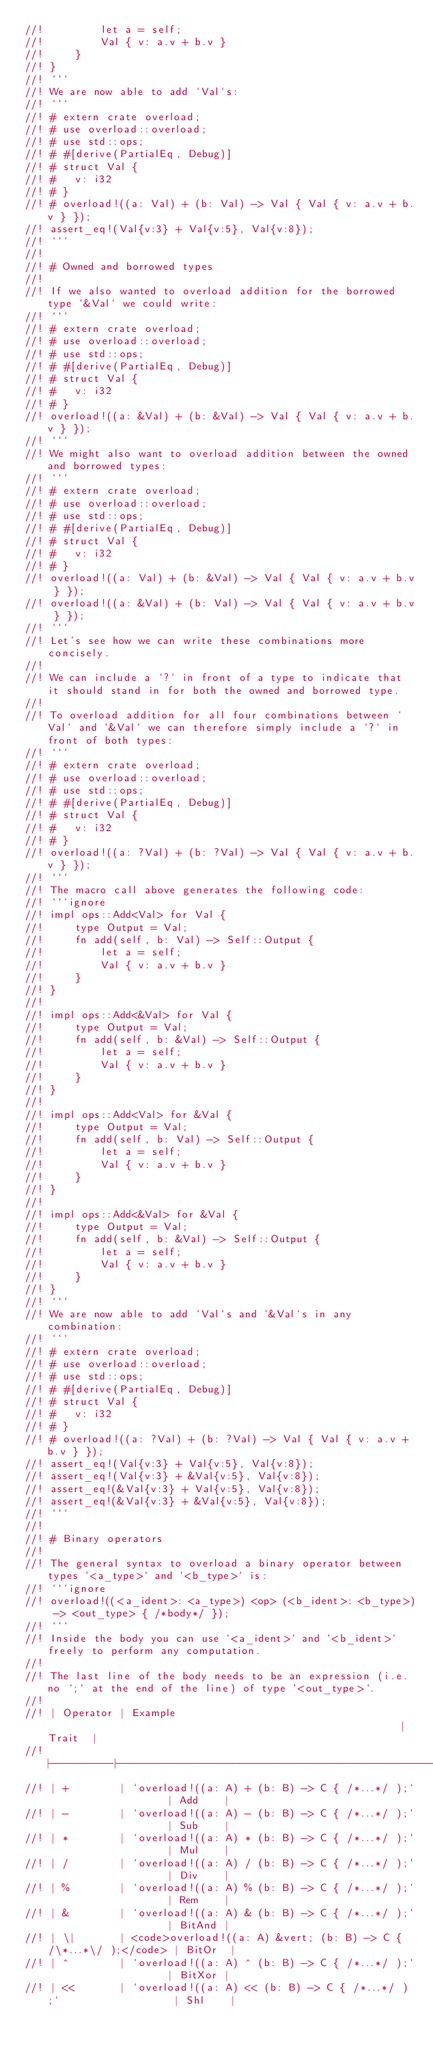<code> <loc_0><loc_0><loc_500><loc_500><_Rust_>//!         let a = self;
//!         Val { v: a.v + b.v }
//!     }
//! }
//! ```
//! We are now able to add `Val`s:
//! ```
//! # extern crate overload;
//! # use overload::overload;
//! # use std::ops;
//! # #[derive(PartialEq, Debug)]
//! # struct Val {
//! #   v: i32
//! # }
//! # overload!((a: Val) + (b: Val) -> Val { Val { v: a.v + b.v } });
//! assert_eq!(Val{v:3} + Val{v:5}, Val{v:8});
//! ```
//! 
//! # Owned and borrowed types
//! 
//! If we also wanted to overload addition for the borrowed type `&Val` we could write:
//! ```
//! # extern crate overload;
//! # use overload::overload;
//! # use std::ops;
//! # #[derive(PartialEq, Debug)]
//! # struct Val {
//! #   v: i32
//! # }
//! overload!((a: &Val) + (b: &Val) -> Val { Val { v: a.v + b.v } });
//! ```
//! We might also want to overload addition between the owned and borrowed types:
//! ```
//! # extern crate overload;
//! # use overload::overload;
//! # use std::ops;
//! # #[derive(PartialEq, Debug)]
//! # struct Val {
//! #   v: i32
//! # }
//! overload!((a: Val) + (b: &Val) -> Val { Val { v: a.v + b.v } });
//! overload!((a: &Val) + (b: Val) -> Val { Val { v: a.v + b.v } });
//! ```
//! Let's see how we can write these combinations more concisely.
//! 
//! We can include a `?` in front of a type to indicate that it should stand in for both the owned and borrowed type.
//! 
//! To overload addition for all four combinations between `Val` and `&Val` we can therefore simply include a `?` in front of both types:
//! ```
//! # extern crate overload;
//! # use overload::overload;
//! # use std::ops;
//! # #[derive(PartialEq, Debug)]
//! # struct Val {
//! #   v: i32
//! # }
//! overload!((a: ?Val) + (b: ?Val) -> Val { Val { v: a.v + b.v } });
//! ```
//! The macro call above generates the following code:
//! ```ignore
//! impl ops::Add<Val> for Val {
//!     type Output = Val;
//!     fn add(self, b: Val) -> Self::Output {
//!         let a = self;
//!         Val { v: a.v + b.v }
//!     }
//! }
//! 
//! impl ops::Add<&Val> for Val {
//!     type Output = Val;
//!     fn add(self, b: &Val) -> Self::Output {
//!         let a = self;
//!         Val { v: a.v + b.v }
//!     }
//! }
//! 
//! impl ops::Add<Val> for &Val {
//!     type Output = Val;
//!     fn add(self, b: Val) -> Self::Output {
//!         let a = self;
//!         Val { v: a.v + b.v }
//!     }
//! }
//! 
//! impl ops::Add<&Val> for &Val {
//!     type Output = Val;
//!     fn add(self, b: &Val) -> Self::Output {
//!         let a = self;
//!         Val { v: a.v + b.v }
//!     }
//! }
//! ``` 
//! We are now able to add `Val`s and `&Val`s in any combination:
//! ```
//! # extern crate overload;
//! # use overload::overload;
//! # use std::ops;
//! # #[derive(PartialEq, Debug)]
//! # struct Val {
//! #   v: i32
//! # }
//! # overload!((a: ?Val) + (b: ?Val) -> Val { Val { v: a.v + b.v } });
//! assert_eq!(Val{v:3} + Val{v:5}, Val{v:8});
//! assert_eq!(Val{v:3} + &Val{v:5}, Val{v:8});
//! assert_eq!(&Val{v:3} + Val{v:5}, Val{v:8});
//! assert_eq!(&Val{v:3} + &Val{v:5}, Val{v:8});
//! ```
//!
//! # Binary operators
//! 
//! The general syntax to overload a binary operator between types `<a_type>` and `<b_type>` is:
//! ```ignore
//! overload!((<a_ident>: <a_type>) <op> (<b_ident>: <b_type>) -> <out_type> { /*body*/ });
//! ```
//! Inside the body you can use `<a_ident>` and `<b_ident>` freely to perform any computation.
//! 
//! The last line of the body needs to be an expression (i.e. no `;` at the end of the line) of type `<out_type>`.
//! 
//! | Operator | Example                                                         | Trait  |
//! |----------|-----------------------------------------------------------------|--------|
//! | +        | `overload!((a: A) + (b: B) -> C { /*...*/ );`                   | Add    |           
//! | -        | `overload!((a: A) - (b: B) -> C { /*...*/ );`                   | Sub    |
//! | *        | `overload!((a: A) * (b: B) -> C { /*...*/ );`                   | Mul    |
//! | /        | `overload!((a: A) / (b: B) -> C { /*...*/ );`                   | Div    |
//! | %        | `overload!((a: A) % (b: B) -> C { /*...*/ );`                   | Rem    |
//! | &        | `overload!((a: A) & (b: B) -> C { /*...*/ );`                   | BitAnd |
//! | \|       | <code>overload!((a: A) &vert; (b: B) -> C { /\*...*\/ );</code> | BitOr  |
//! | ^        | `overload!((a: A) ^ (b: B) -> C { /*...*/ );`                   | BitXor |
//! | <<       | `overload!((a: A) << (b: B) -> C { /*...*/ );`                  | Shl    |</code> 